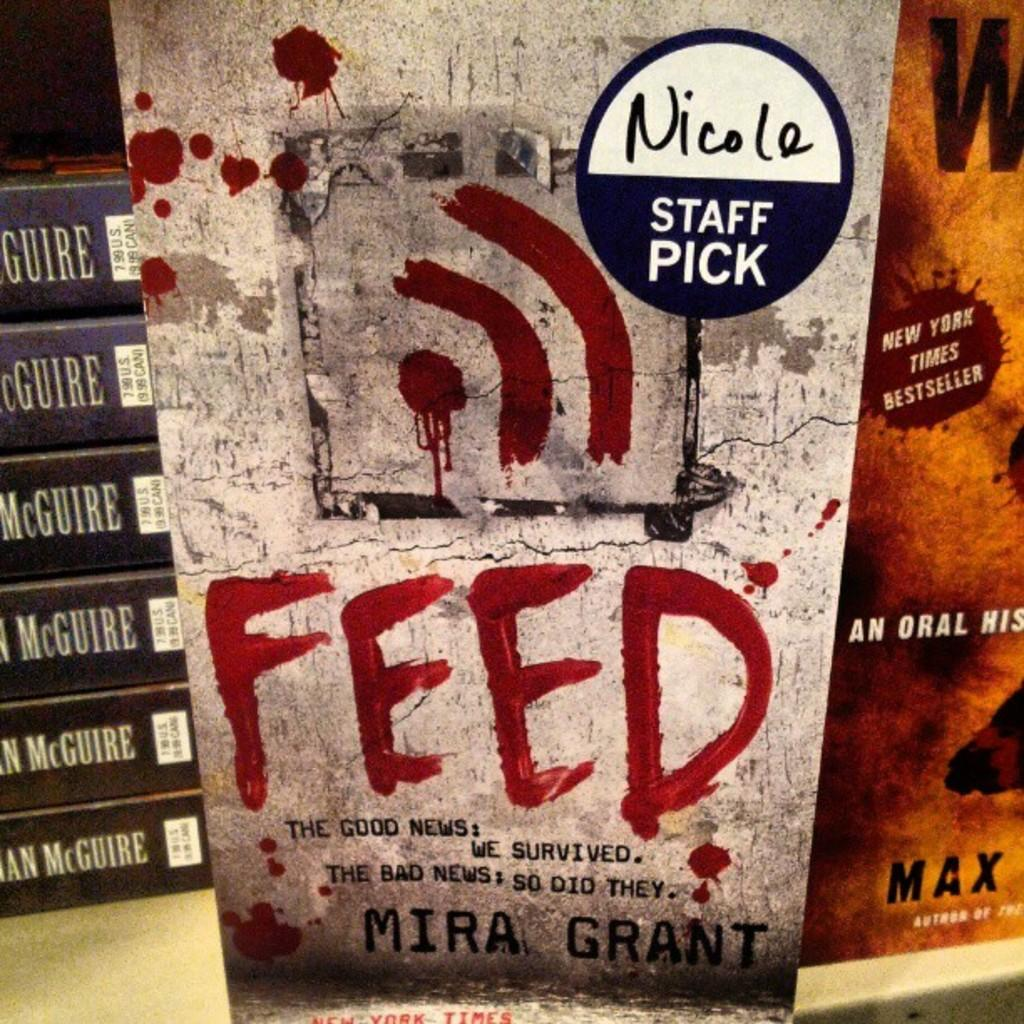<image>
Summarize the visual content of the image. a sign that has the word feed on iy 